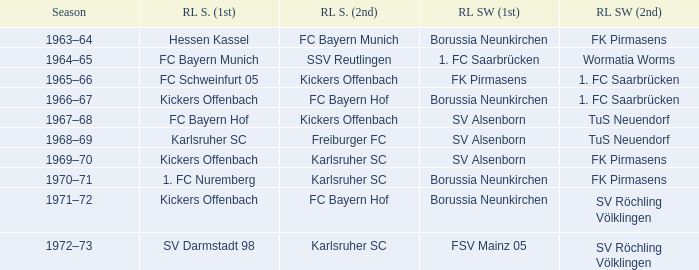What season was Freiburger FC the RL Süd (2nd) team? 1968–69. 